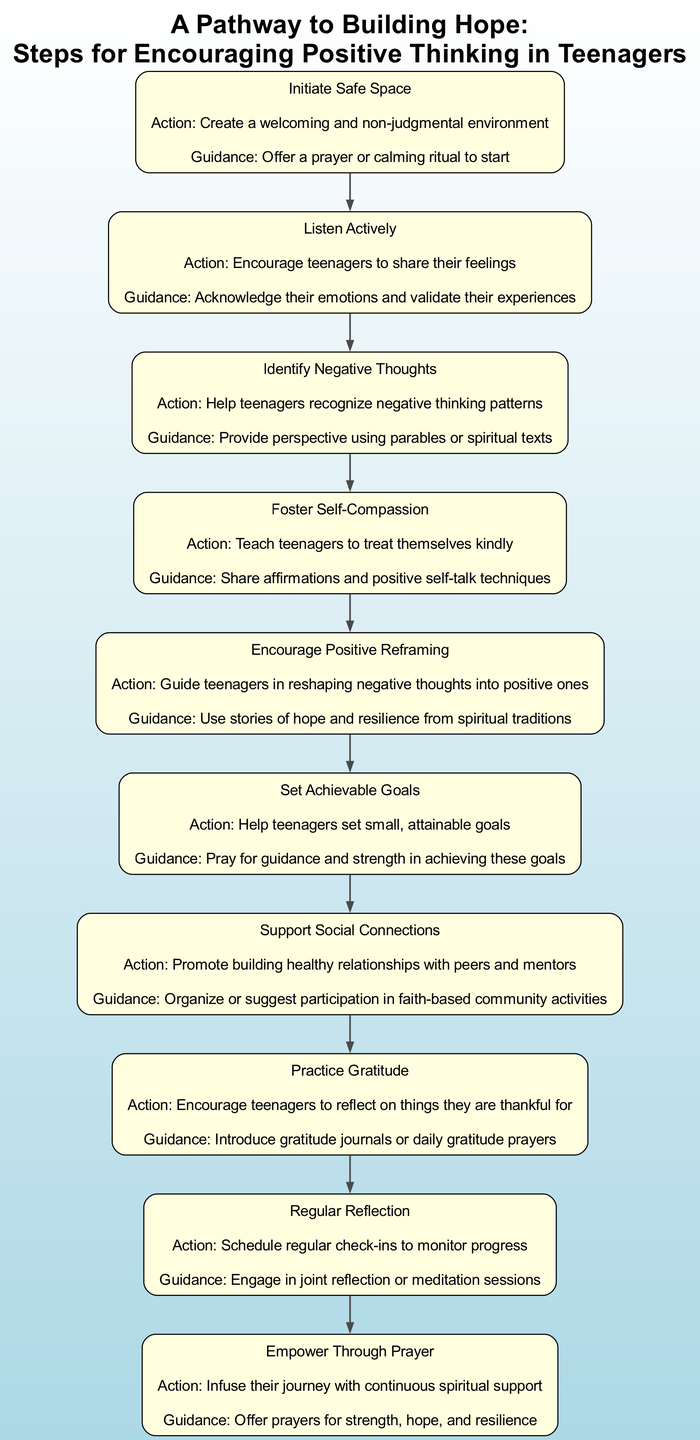What is the first step in the pathway? The first step listed in the diagram is "Initiate Safe Space," which is the beginning of the flow, indicating the starting point of the process toward building hope.
Answer: Initiate Safe Space How many steps are there in total? By counting the nodes representing each step in the diagram, we can find that there are ten distinct steps shown in the flow chart.
Answer: Ten What action is associated with "Practice Gratitude"? The action for "Practice Gratitude" is reflected in the diagram as "Encourage teenagers to reflect on things they are thankful for," detailing the purpose of that step in the pathway.
Answer: Encourage teenagers to reflect on things they are thankful for What is the spiritual guidance offered in "Foster Self-Compassion"? The spiritual guidance related to "Foster Self-Compassion" is "Share affirmations and positive self-talk techniques," which aligns with the goal of helping teenagers treat themselves kindly.
Answer: Share affirmations and positive self-talk techniques Which step follows "Identify Negative Thoughts"? By tracing the flow from "Identify Negative Thoughts," we observe that the next step in the pathway is "Foster Self-Compassion," continuing the process of building hope.
Answer: Foster Self-Compassion Which two steps emphasize the importance of support systems? The steps that highlight support systems are "Support Social Connections" and "Empower Through Prayer," as they both involve nurturing relationships and spiritual support.
Answer: Support Social Connections and Empower Through Prayer What is the last step in the pathway? The final step as delineated by the flow chart is "Empower Through Prayer," which signifies the culmination of the journey toward instilling hope through continuous support.
Answer: Empower Through Prayer How does "Encourage Positive Reframing" relate to "Identify Negative Thoughts"? The relationship is that "Encourage Positive Reframing" directly follows "Identify Negative Thoughts," indicating a progression from recognizing negative thoughts to reframing them positively.
Answer: Directly follows What technique is suggested for "Set Achievable Goals"? The technique mentioned for "Set Achievable Goals" is to "Help teenagers set small, attainable goals," which guides the teenagers to create manageable targets for themselves.
Answer: Help teenagers set small, attainable goals What is one method to practice gratitude as described in the diagram? One method to practice gratitude mentioned in the diagram is "Introduce gratitude journals or daily gratitude prayers," providing a structured way for teenagers to reflect on their gratitude.
Answer: Introduce gratitude journals or daily gratitude prayers 